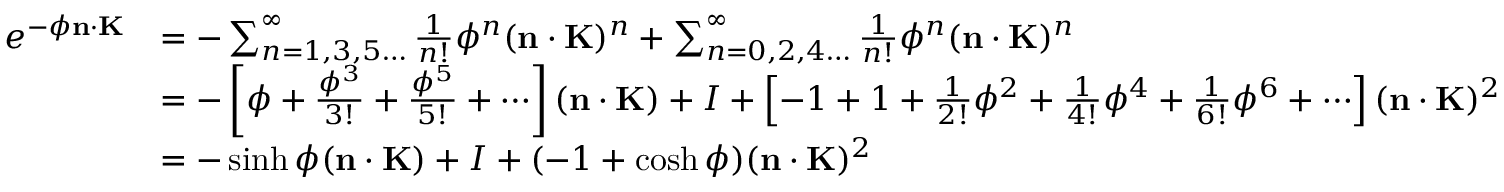<formula> <loc_0><loc_0><loc_500><loc_500>{ \begin{array} { r l } { e ^ { - \phi n \cdot K } } & { = - \sum _ { n = 1 , 3 , 5 \dots } ^ { \infty } { \frac { 1 } { n ! } } \phi ^ { n } ( n \cdot K ) ^ { n } + \sum _ { n = 0 , 2 , 4 \dots } ^ { \infty } { \frac { 1 } { n ! } } \phi ^ { n } ( n \cdot K ) ^ { n } } \\ & { = - \left [ \phi + { \frac { \phi ^ { 3 } } { 3 ! } } + { \frac { \phi ^ { 5 } } { 5 ! } } + \cdots \right ] ( n \cdot K ) + I + \left [ - 1 + 1 + { \frac { 1 } { 2 ! } } \phi ^ { 2 } + { \frac { 1 } { 4 ! } } \phi ^ { 4 } + { \frac { 1 } { 6 ! } } \phi ^ { 6 } + \cdots \right ] ( n \cdot K ) ^ { 2 } } \\ & { = - \sinh \phi ( n \cdot K ) + I + ( - 1 + \cosh \phi ) ( n \cdot K ) ^ { 2 } } \end{array} }</formula> 